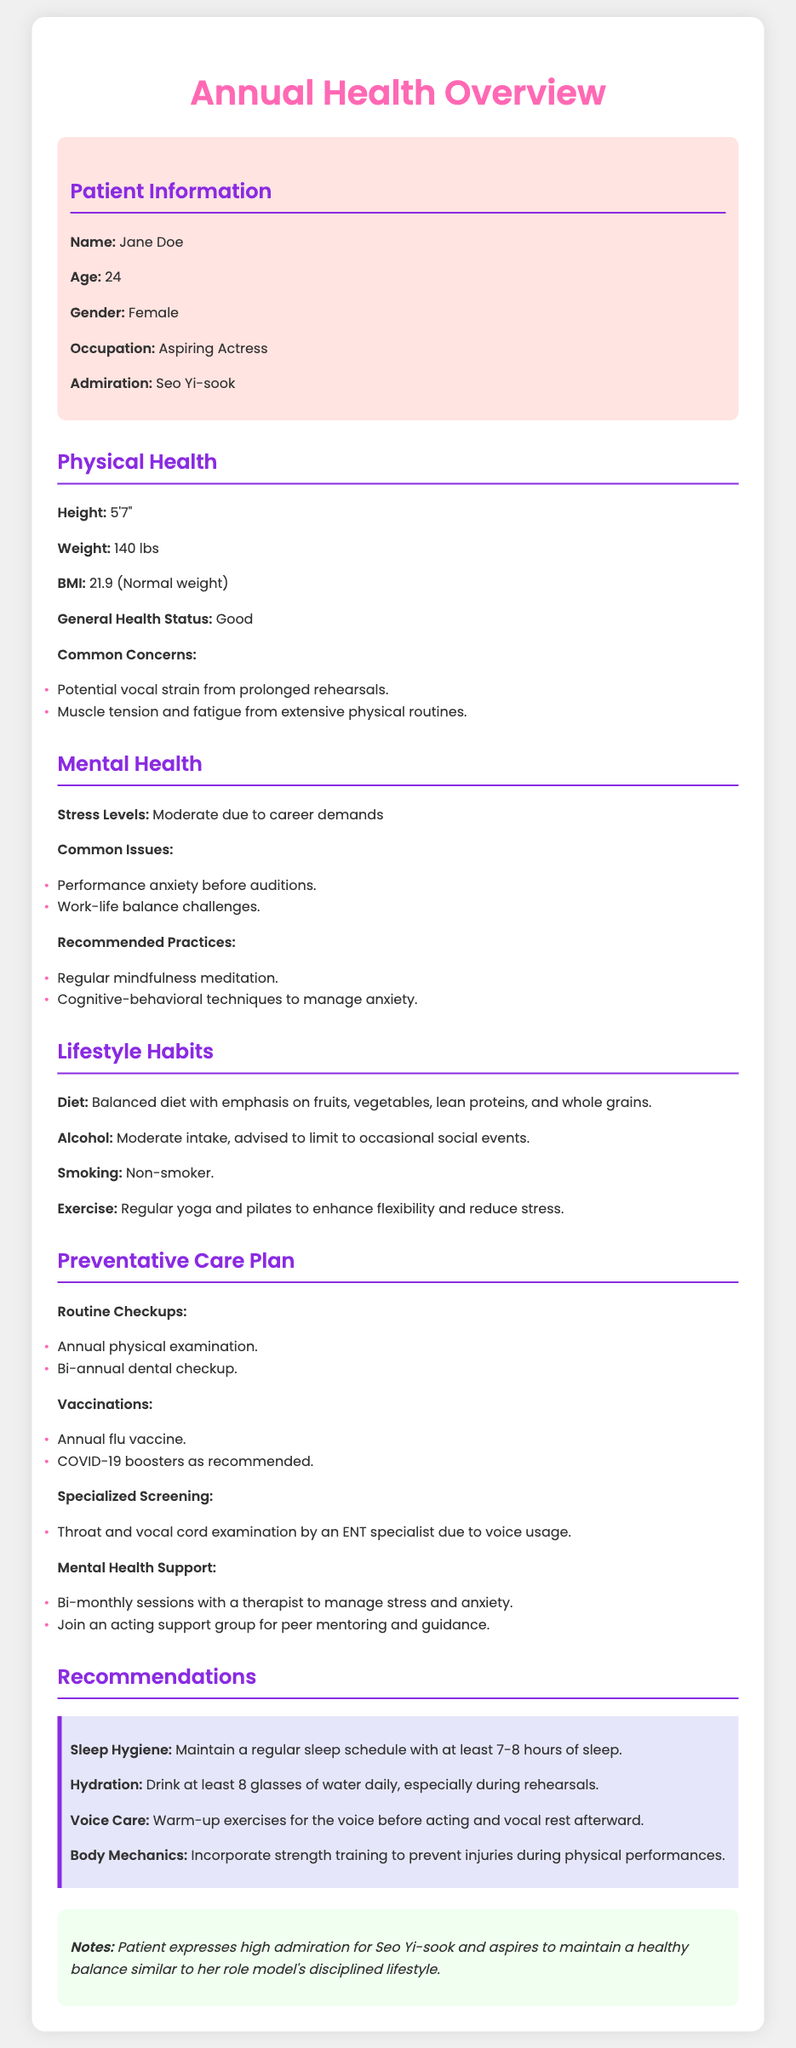What is the patient's name? The patient's name is mentioned at the top of the document in the patient information section.
Answer: Jane Doe What is the patient's age? The patient's age is provided directly in the patient information section.
Answer: 24 What is the patient's weight? The patient's weight is listed under the physical health section.
Answer: 140 lbs What common issues does the patient face related to mental health? The document lists specific common issues related to mental health under the mental health section.
Answer: Performance anxiety before auditions What is the patient's BMI? The BMI value is provided in the physical health section.
Answer: 21.9 What type of vaccination is the patient advised to get annually? The vaccination is mentioned under the preventative care plan section.
Answer: Annual flu vaccine How often should the patient have therapy sessions? The frequency of therapy sessions is specified in the mental health support part of the preventative care plan.
Answer: Bi-monthly What is the recommended amount of sleep hours? The sleep hygiene recommendation includes a specific number of hours for sleep.
Answer: 7-8 hours What specialized screening is suggested for the patient? The specialized screening is outlined in the preventative care plan section.
Answer: Throat and vocal cord examination by an ENT specialist 